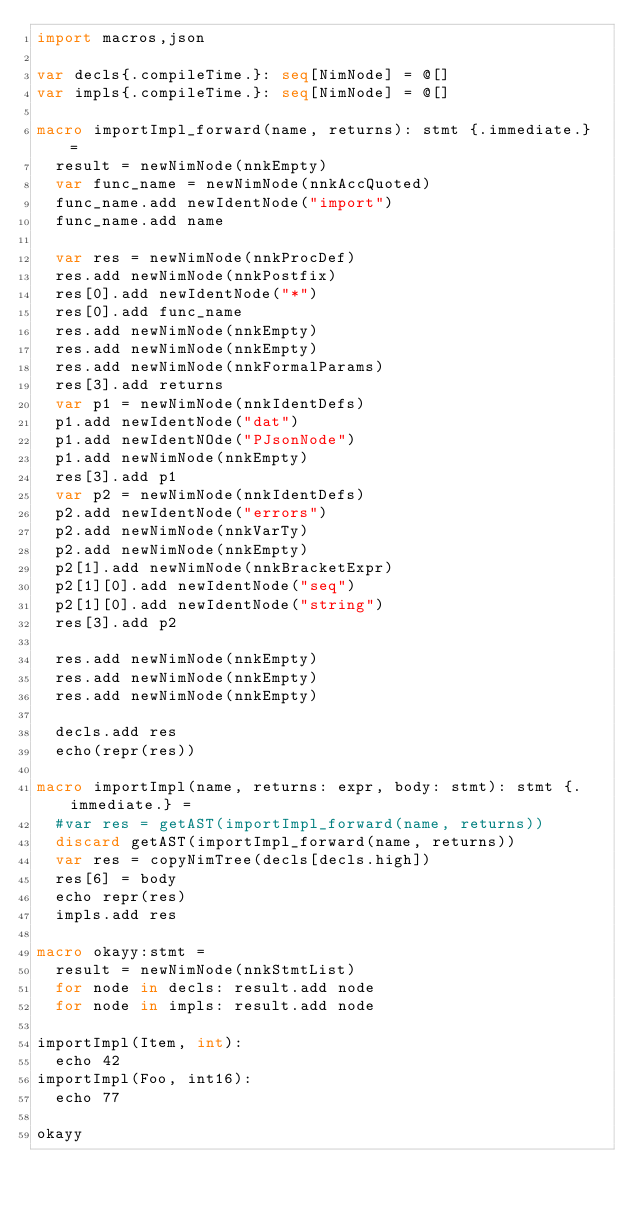<code> <loc_0><loc_0><loc_500><loc_500><_Nim_>import macros,json

var decls{.compileTime.}: seq[NimNode] = @[]
var impls{.compileTime.}: seq[NimNode] = @[]

macro importImpl_forward(name, returns): stmt {.immediate.} =
  result = newNimNode(nnkEmpty)
  var func_name = newNimNode(nnkAccQuoted)
  func_name.add newIdentNode("import")
  func_name.add name

  var res = newNimNode(nnkProcDef)
  res.add newNimNode(nnkPostfix)
  res[0].add newIdentNode("*")
  res[0].add func_name
  res.add newNimNode(nnkEmpty)
  res.add newNimNode(nnkEmpty)
  res.add newNimNode(nnkFormalParams)
  res[3].add returns
  var p1 = newNimNode(nnkIdentDefs)
  p1.add newIdentNode("dat")
  p1.add newIdentNOde("PJsonNode")
  p1.add newNimNode(nnkEmpty)
  res[3].add p1
  var p2 = newNimNode(nnkIdentDefs)
  p2.add newIdentNode("errors")
  p2.add newNimNode(nnkVarTy)
  p2.add newNimNode(nnkEmpty)
  p2[1].add newNimNode(nnkBracketExpr)
  p2[1][0].add newIdentNode("seq")
  p2[1][0].add newIdentNode("string")
  res[3].add p2

  res.add newNimNode(nnkEmpty)
  res.add newNimNode(nnkEmpty)
  res.add newNimNode(nnkEmpty)

  decls.add res
  echo(repr(res))

macro importImpl(name, returns: expr, body: stmt): stmt {.immediate.} =
  #var res = getAST(importImpl_forward(name, returns))
  discard getAST(importImpl_forward(name, returns))
  var res = copyNimTree(decls[decls.high])
  res[6] = body
  echo repr(res)
  impls.add res

macro okayy:stmt =
  result = newNimNode(nnkStmtList)
  for node in decls: result.add node
  for node in impls: result.add node

importImpl(Item, int):
  echo 42
importImpl(Foo, int16):
  echo 77

okayy
</code> 